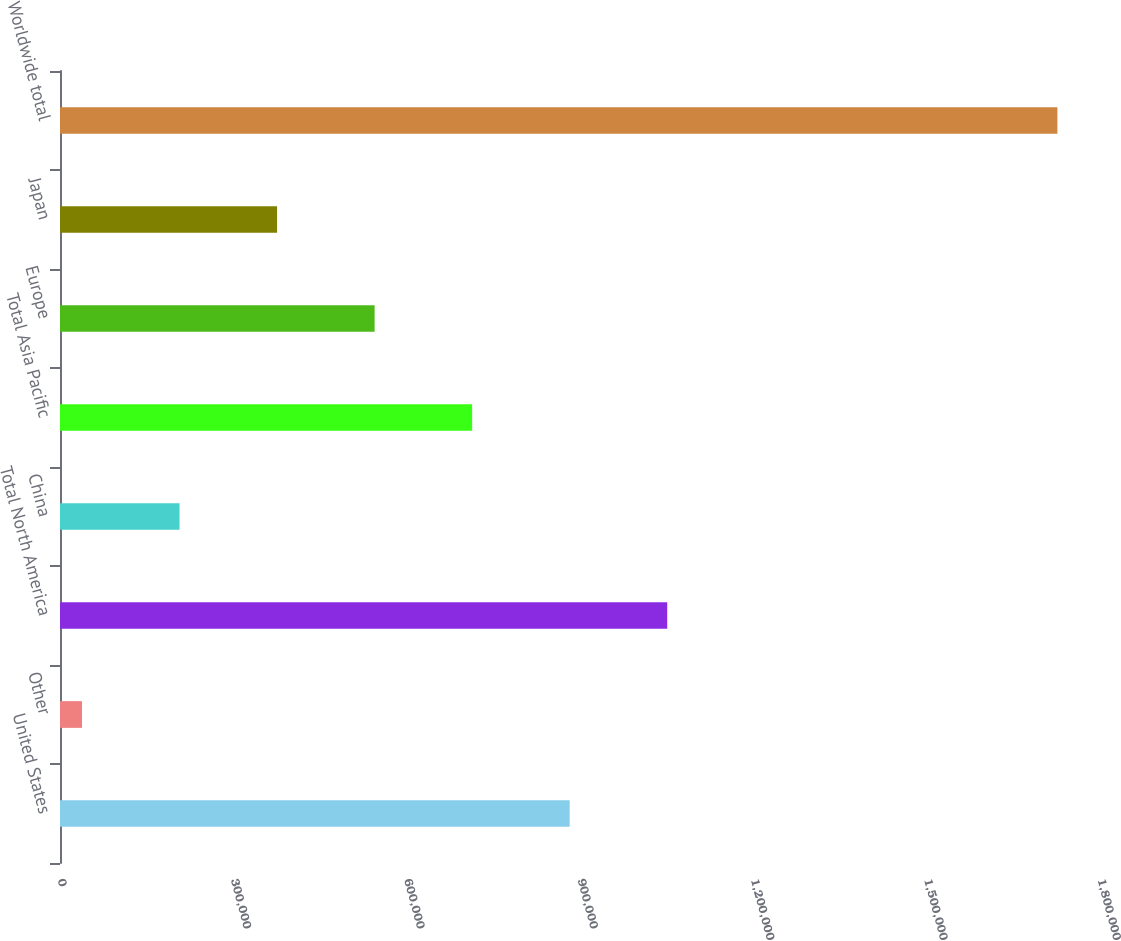Convert chart to OTSL. <chart><loc_0><loc_0><loc_500><loc_500><bar_chart><fcel>United States<fcel>Other<fcel>Total North America<fcel>China<fcel>Total Asia Pacific<fcel>Europe<fcel>Japan<fcel>Worldwide total<nl><fcel>882162<fcel>38074<fcel>1.05098e+06<fcel>206892<fcel>713344<fcel>544527<fcel>375709<fcel>1.72625e+06<nl></chart> 